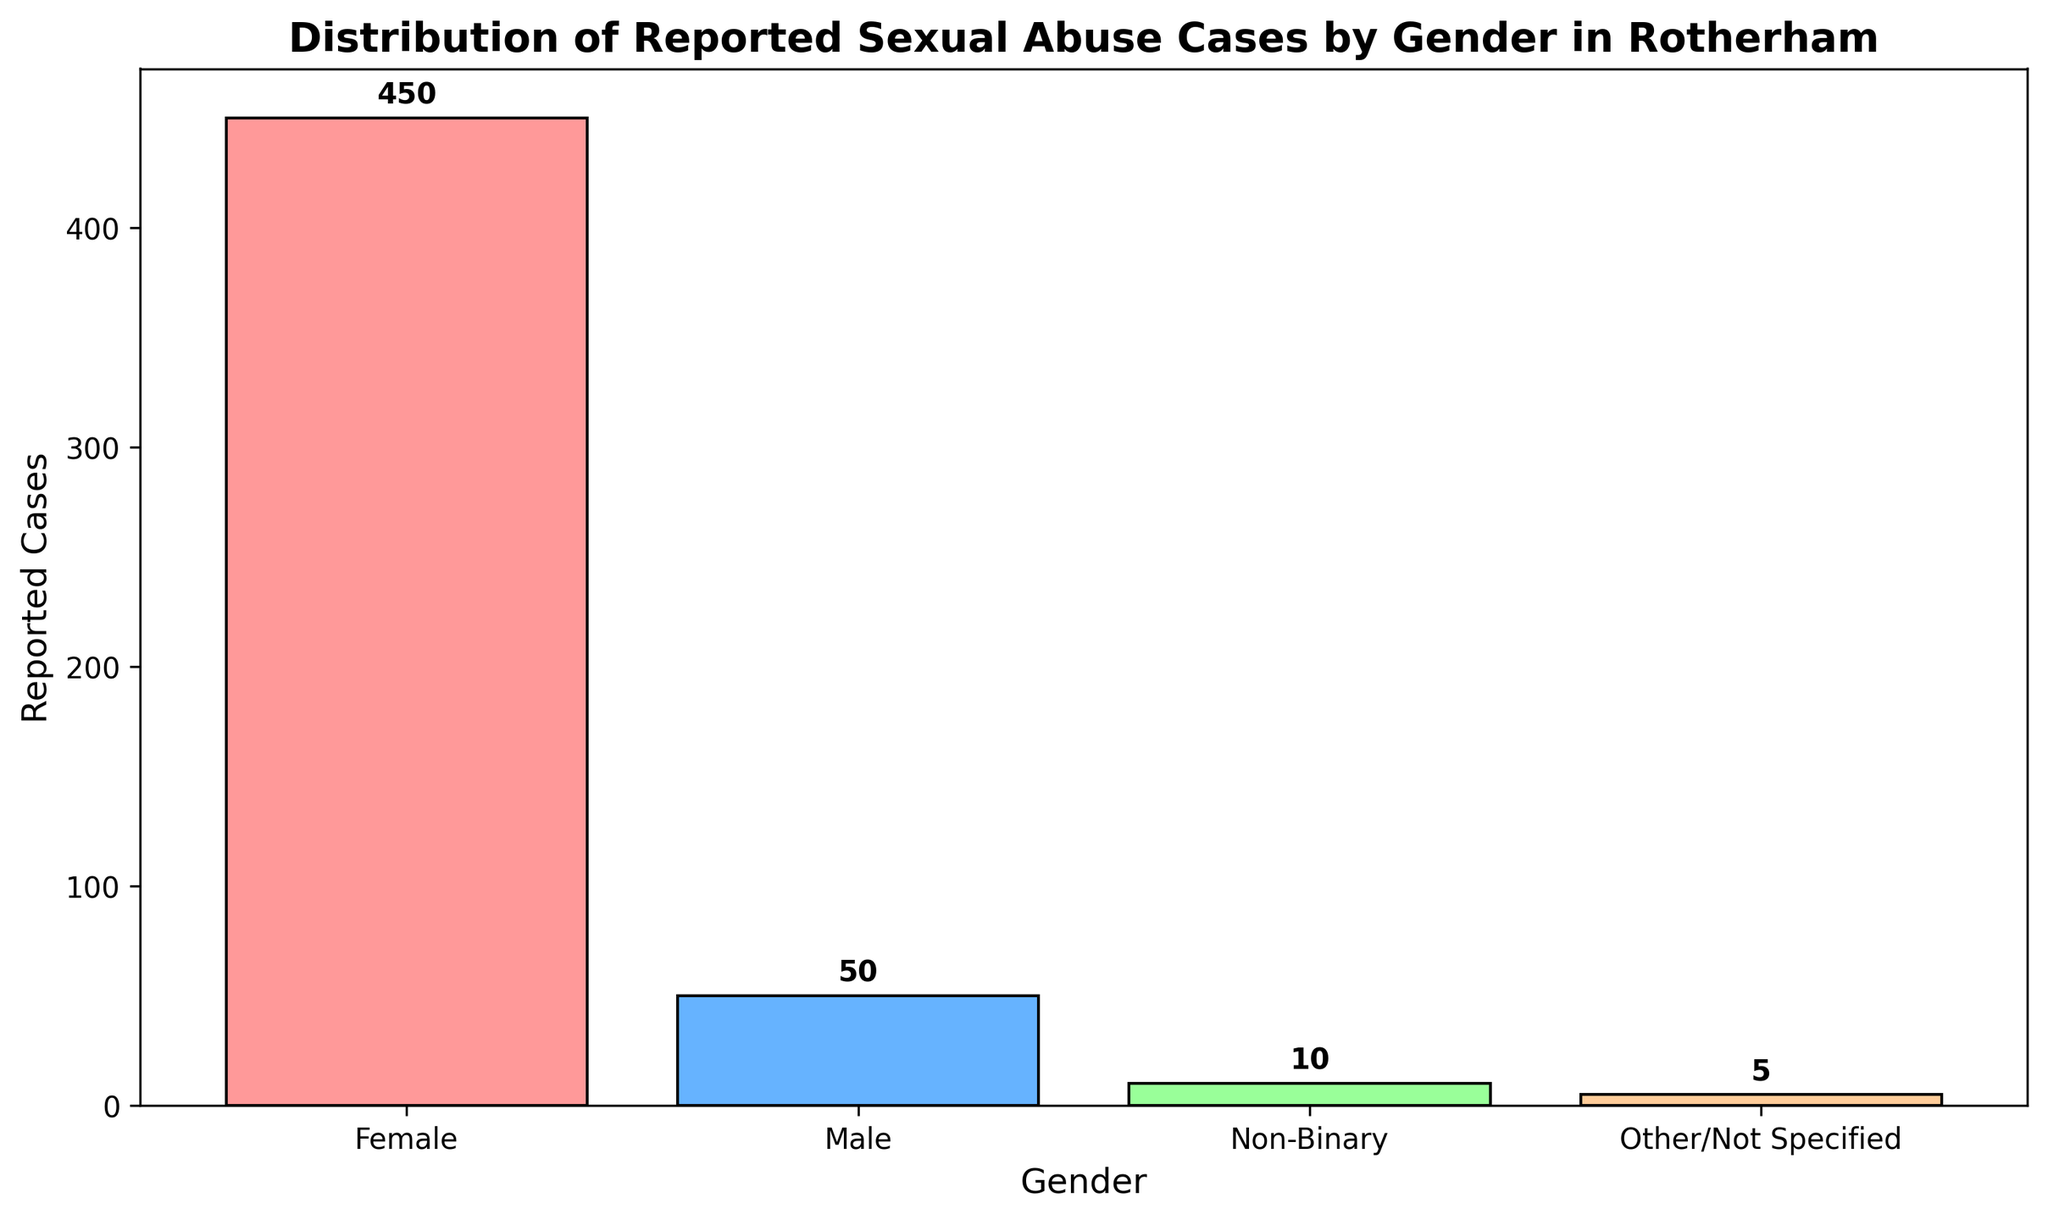What is the total number of reported sexual abuse cases? To find the total number of reported sexual abuse cases, add the reported cases for each gender: 450 (Female) + 50 (Male) + 10 (Non-Binary) + 5 (Other/Not Specified) = 515
Answer: 515 Which gender has the highest number of reported cases? By comparing the bar heights and the annotated values, the Female gender has the highest number of reported cases with a total of 450.
Answer: Female How many more reported cases are there for females compared to males? Subtract the number of reported cases for males (50) from the number of reported cases for females (450): 450 - 50 = 400
Answer: 400 What percentage of the total reported cases are reported by Non-Binary individuals? First, find the total number of reported cases (515). Then, calculate the percentage for Non-Binary individuals: (10 / 515) * 100 ≈ 1.94%
Answer: 1.94% How many fewer reported cases are there for Other/Not Specified compared to Non-Binary? Subtract the number of reported cases for Other/Not Specified (5) from the number of reported cases for Non-Binary (10): 10 - 5 = 5
Answer: 5 Rank the genders from highest to lowest based on the number of reported cases. The ranking based on the reported cases from highest to lowest is: Female (450), Male (50), Non-Binary (10), Other/Not Specified (5)
Answer: Female, Male, Non-Binary, Other/Not Specified What is the average number of reported cases per gender category? Total reported cases are 515, and there are 4 gender categories. Calculate the average by dividing the total number of cases by the number of categories: 515 / 4 = 128.75
Answer: 128.75 Which gender category has the smallest number of reported cases, and how many are there? By examining the bar heights and annotations, Other/Not Specified has the smallest number of reported cases, which is 5.
Answer: Other/Not Specified, 5 How does the number of reported cases for males compare to the number of cases for Non-Binary individuals? The number of reported cases for males (50) is greater than for Non-Binary individuals (10). Specifically, 50 - 10 = 40 more cases for males.
Answer: Males have 40 more cases What color is the bar representing reported cases for the Female gender? From the visual attributes, the bar representing reported cases for the Female gender is colored in red.
Answer: Red 